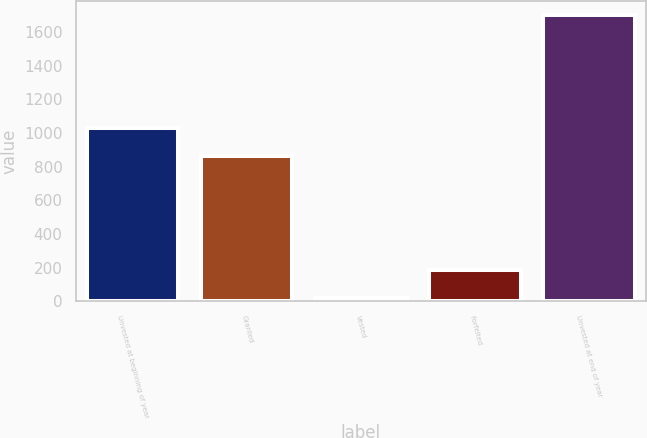Convert chart. <chart><loc_0><loc_0><loc_500><loc_500><bar_chart><fcel>Unvested at beginning of year<fcel>Granted<fcel>Vested<fcel>Forfeited<fcel>Unvested at end of year<nl><fcel>1031.3<fcel>863<fcel>18<fcel>186.3<fcel>1701<nl></chart> 